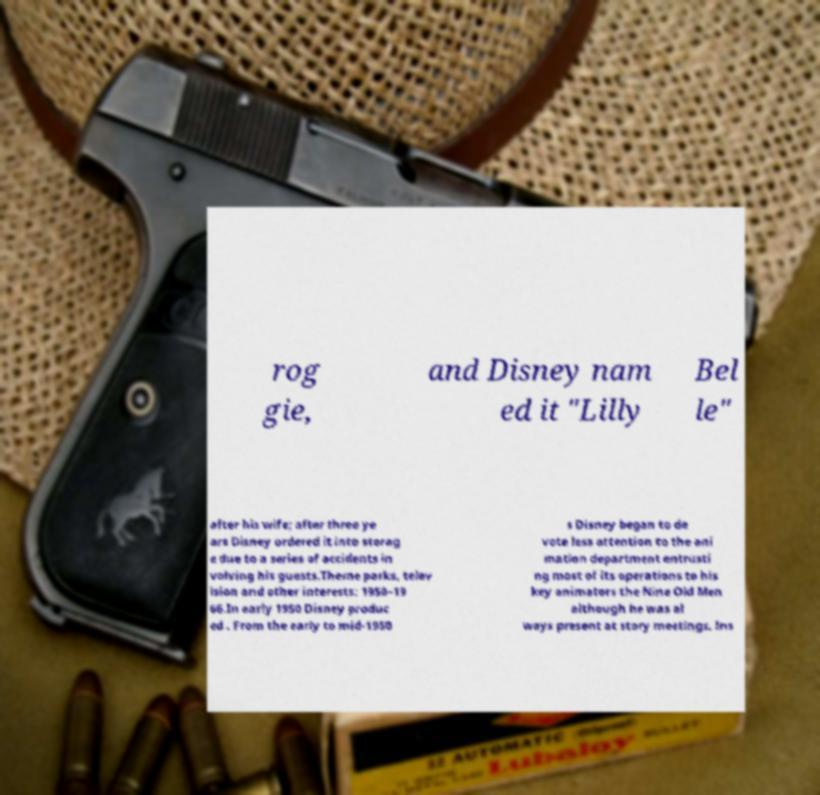Could you extract and type out the text from this image? rog gie, and Disney nam ed it "Lilly Bel le" after his wife; after three ye ars Disney ordered it into storag e due to a series of accidents in volving his guests.Theme parks, telev ision and other interests: 1950–19 66.In early 1950 Disney produc ed . From the early to mid-1950 s Disney began to de vote less attention to the ani mation department entrusti ng most of its operations to his key animators the Nine Old Men although he was al ways present at story meetings. Ins 